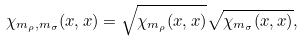Convert formula to latex. <formula><loc_0><loc_0><loc_500><loc_500>\chi _ { m _ { \rho } , m _ { \sigma } } ( x , x ) = \sqrt { \chi _ { m _ { \rho } } ( x , x ) } \sqrt { \chi _ { m _ { \sigma } } ( x , x ) } ,</formula> 